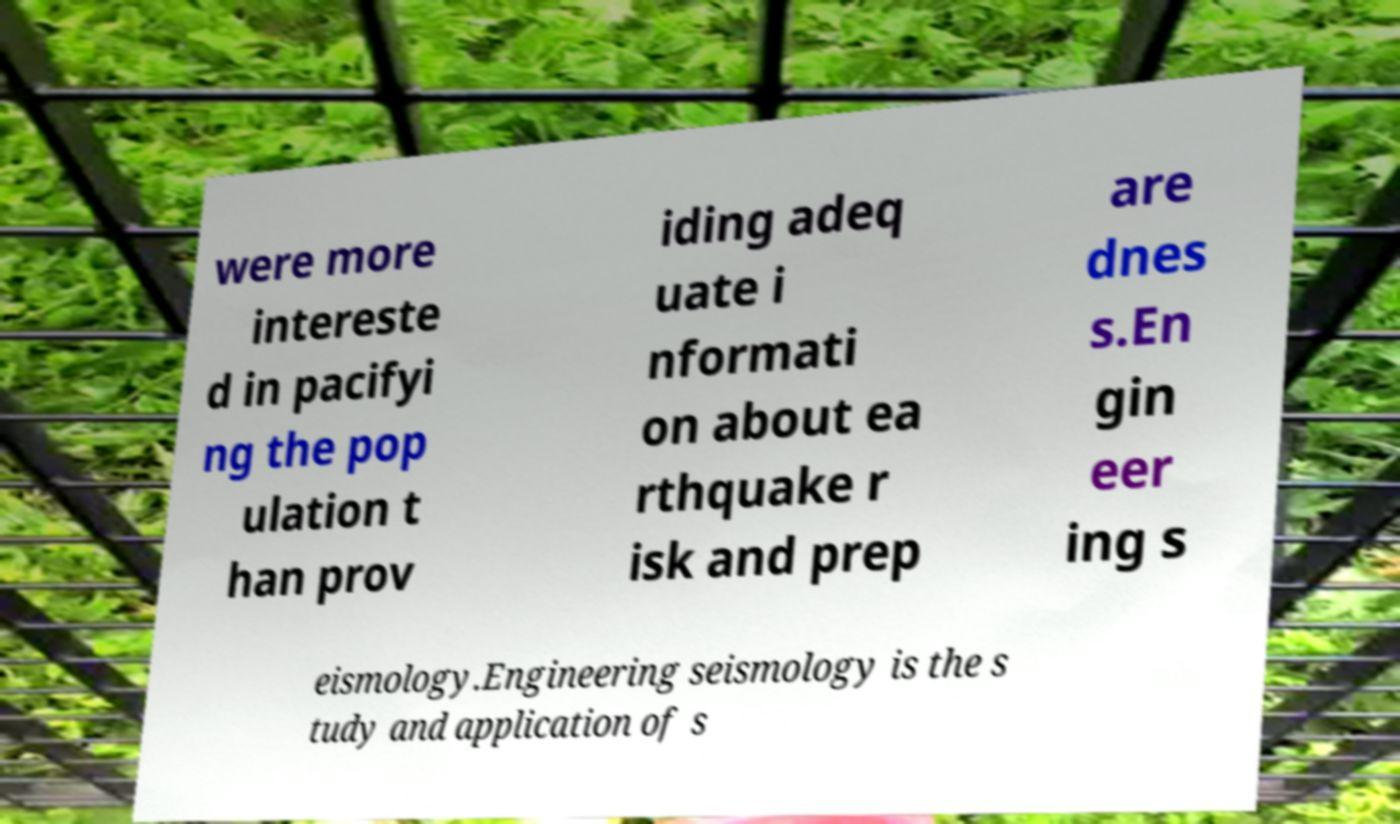What messages or text are displayed in this image? I need them in a readable, typed format. were more intereste d in pacifyi ng the pop ulation t han prov iding adeq uate i nformati on about ea rthquake r isk and prep are dnes s.En gin eer ing s eismology.Engineering seismology is the s tudy and application of s 